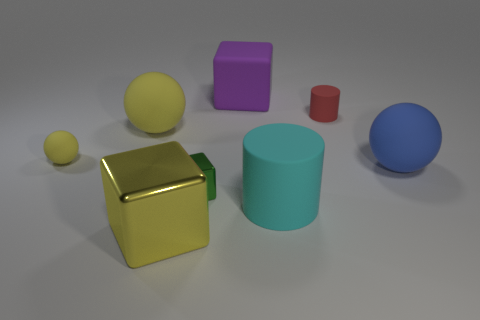There is a blue object that is the same material as the big cyan cylinder; what size is it?
Offer a very short reply. Large. How many yellow metal things have the same shape as the green shiny thing?
Provide a succinct answer. 1. Is the material of the big cylinder the same as the object on the right side of the red thing?
Your response must be concise. Yes. Is the number of large yellow blocks behind the big cyan rubber object greater than the number of metallic blocks?
Offer a terse response. No. What is the shape of the big rubber object that is the same color as the big metal block?
Offer a terse response. Sphere. Are there any gray cylinders that have the same material as the purple cube?
Offer a very short reply. No. Do the big block that is in front of the big purple object and the big yellow object that is behind the blue matte object have the same material?
Ensure brevity in your answer.  No. Is the number of large cylinders that are behind the large yellow sphere the same as the number of red matte things that are in front of the small matte ball?
Make the answer very short. Yes. There is a metal block that is the same size as the cyan rubber cylinder; what is its color?
Provide a short and direct response. Yellow. Are there any small metal cubes that have the same color as the tiny shiny thing?
Provide a short and direct response. No. 